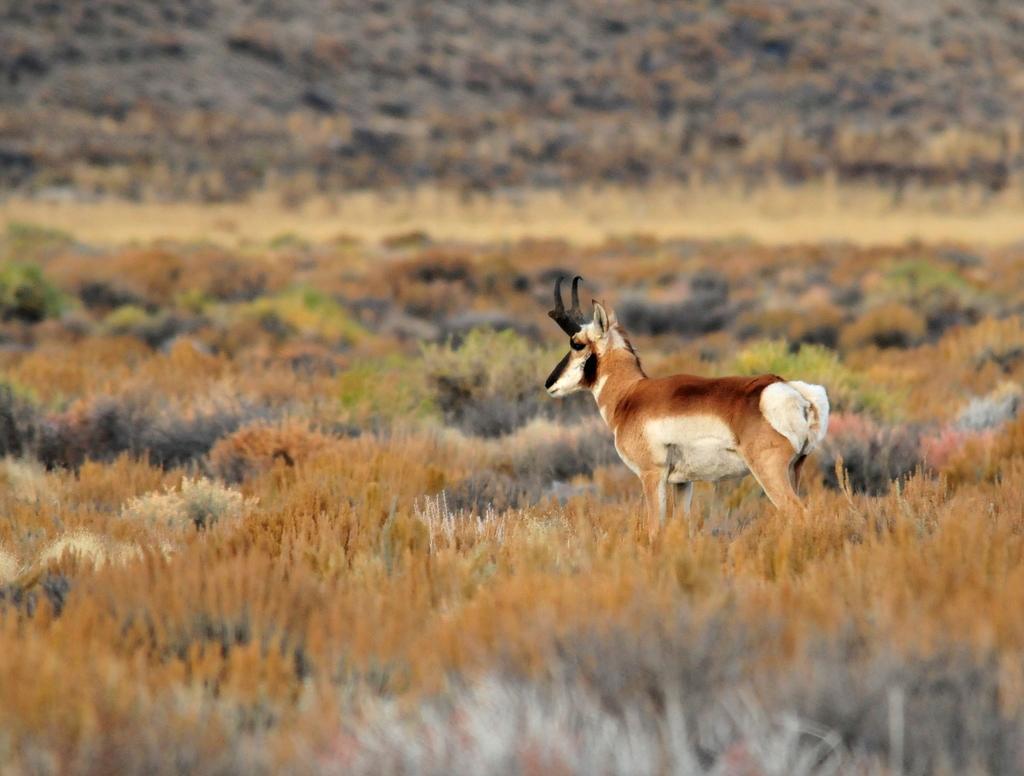Describe this image in one or two sentences. In this picture we can see a deer. There are a few planets visible from left to right. Background is blurry. 